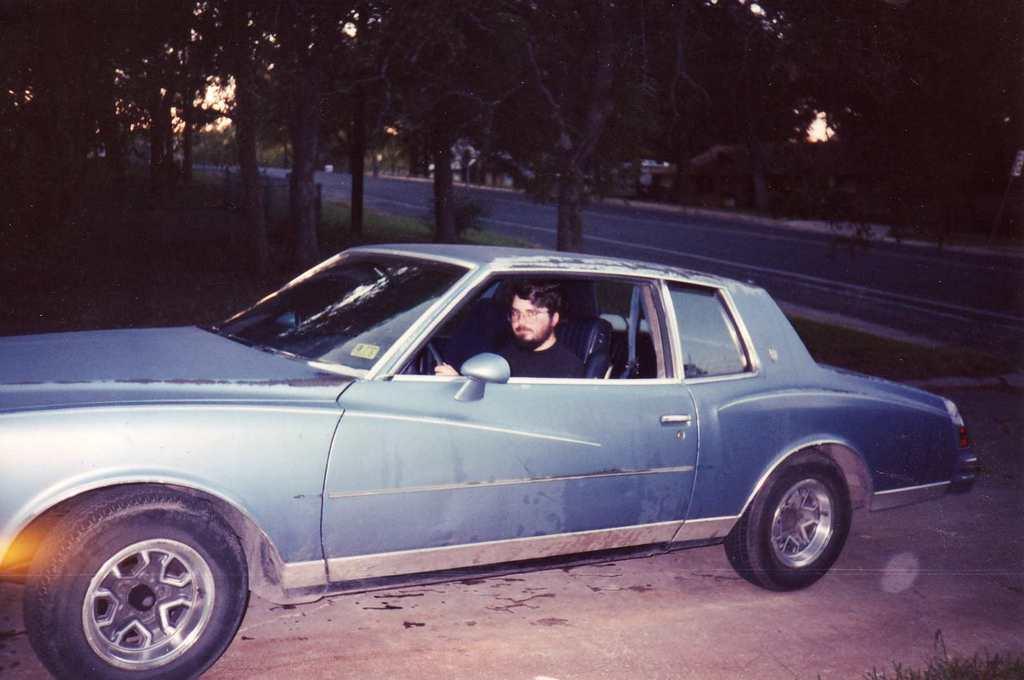Can you describe this image briefly? In this image we can see a person sitting inside the blue car. In the background we can see trees and road. 